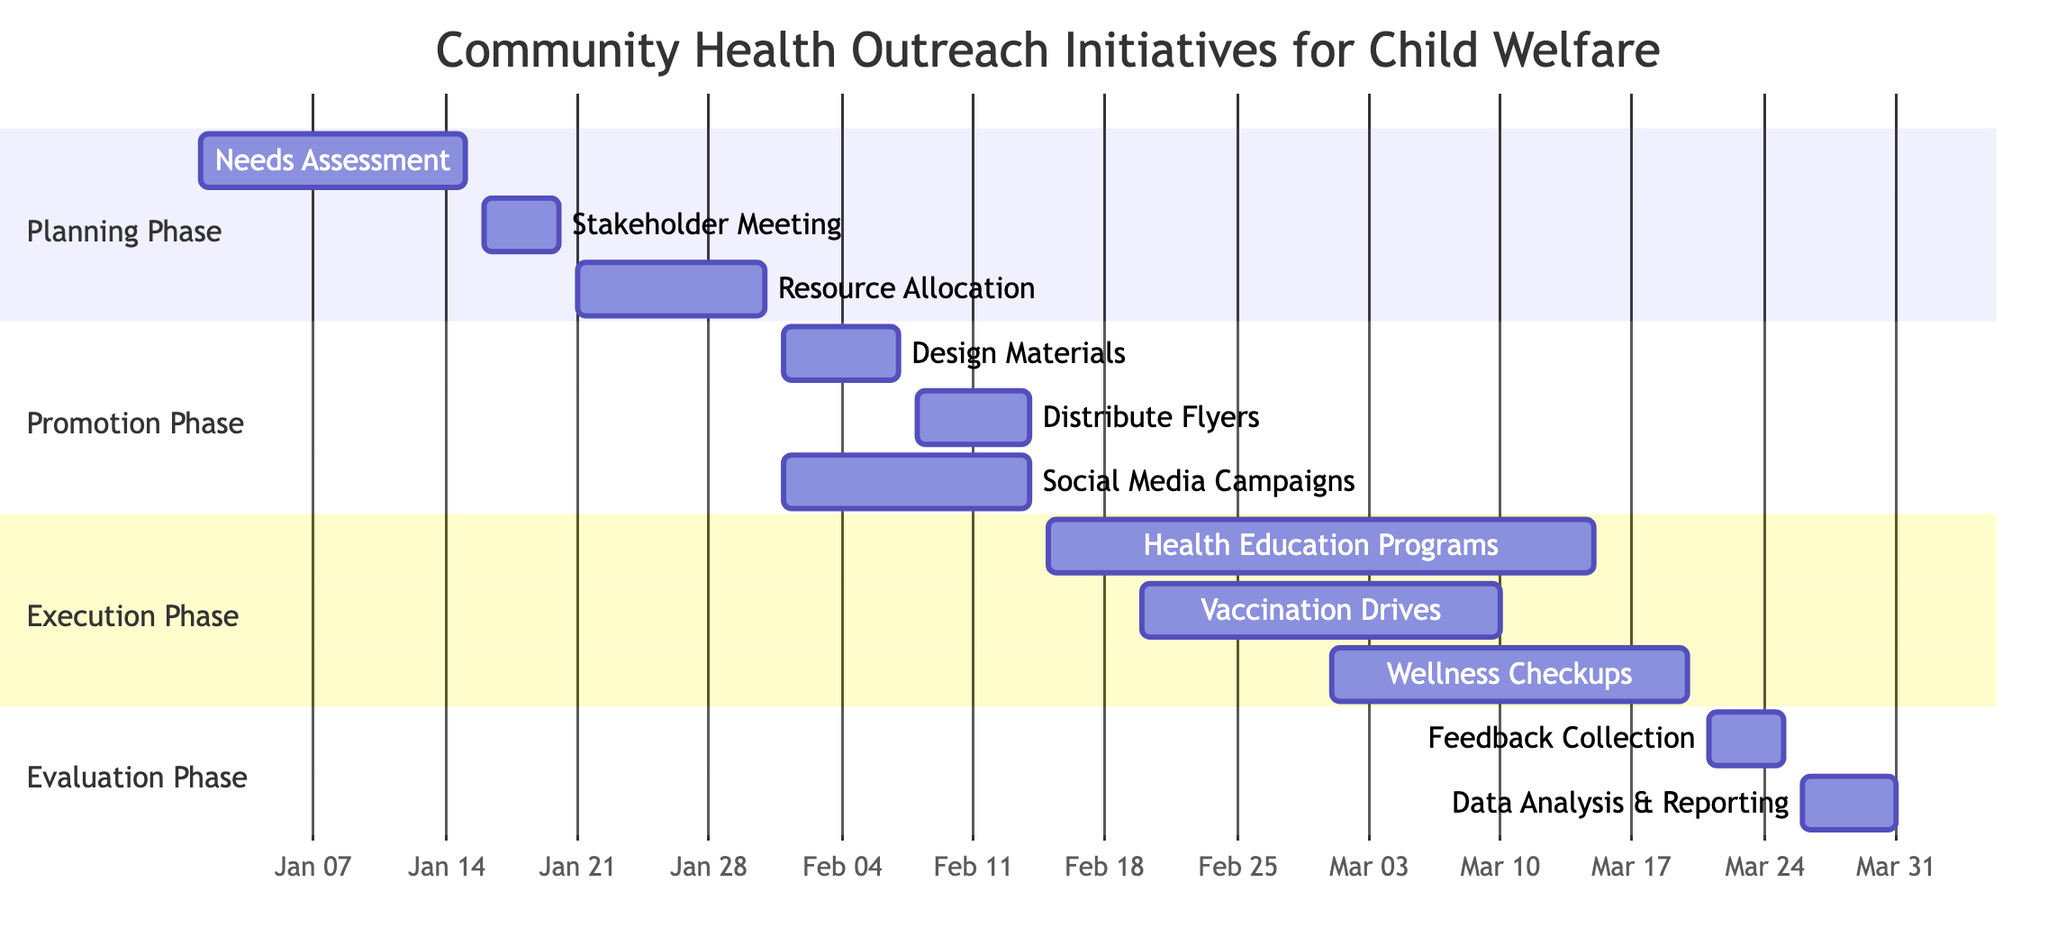What is the duration of the Planning Phase? The Planning Phase includes three subtasks: Needs Assessment (15 days), Stakeholder Meeting (5 days), and Resource Allocation (10 days), making the total duration from January 1 to January 31, which is 31 days.
Answer: 31 days How many subtasks are in the Promotion Phase? The Promotion Phase consists of three subtasks: Design Promotional Materials, Distribute Flyers and Brochures, and Social Media Campaigns. Counting these, we find there are three distinct subtasks.
Answer: 3 What task follows the Resource Allocation in the Planning Phase? The Resource Allocation task ends on January 31, and the next task in the Planning Phase, if we look at the timeline, is the Promotion Phase starting on February 1, which indicates no task immediately follows Resource Allocation. Therefore, there is no task that follows directly after it.
Answer: The Promotion Phase When is the Wellness Checkups task scheduled to occur? The Wellness Checkups task starts on March 1 and ends on March 20, as indicated by the timeline for the Execution Phase of the initiative.
Answer: March 1 to March 20 Which task overlaps with the Social Media Campaigns? The Social Media Campaigns task runs from February 1 to February 14, and it overlaps with both Design Promotional Materials (February 1 to February 7) and Distribute Flyers and Brochures (February 8 to February 14) because both of these tasks are scheduled during the same timeframe.
Answer: Design Promotional Materials and Distribute Flyers and Brochures What is the total duration of the Execution Phase? The Execution Phase consists of three tasks: Health Education Programs (30 days), Vaccination Drives (18 days), and Wellness Checkups (20 days). The phase starts on February 15 and ends on March 20, resulting in a total duration of 35 days for the Execution Phase.
Answer: 35 days 